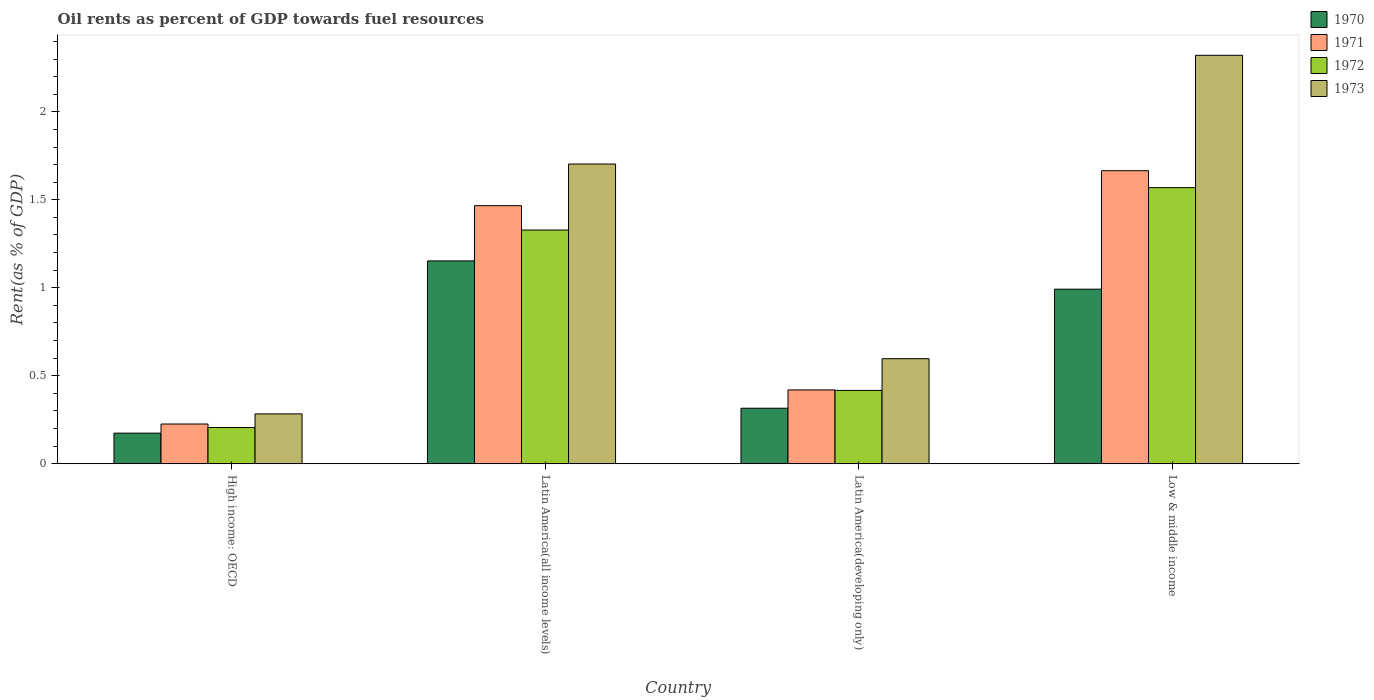How many different coloured bars are there?
Keep it short and to the point. 4. How many groups of bars are there?
Provide a short and direct response. 4. Are the number of bars per tick equal to the number of legend labels?
Your answer should be very brief. Yes. Are the number of bars on each tick of the X-axis equal?
Provide a short and direct response. Yes. How many bars are there on the 1st tick from the left?
Keep it short and to the point. 4. How many bars are there on the 1st tick from the right?
Your answer should be very brief. 4. What is the label of the 1st group of bars from the left?
Ensure brevity in your answer.  High income: OECD. What is the oil rent in 1971 in High income: OECD?
Provide a short and direct response. 0.23. Across all countries, what is the maximum oil rent in 1970?
Your response must be concise. 1.15. Across all countries, what is the minimum oil rent in 1970?
Your answer should be compact. 0.17. In which country was the oil rent in 1970 maximum?
Keep it short and to the point. Latin America(all income levels). In which country was the oil rent in 1973 minimum?
Ensure brevity in your answer.  High income: OECD. What is the total oil rent in 1970 in the graph?
Your response must be concise. 2.63. What is the difference between the oil rent in 1970 in Latin America(all income levels) and that in Latin America(developing only)?
Make the answer very short. 0.84. What is the difference between the oil rent in 1971 in Latin America(all income levels) and the oil rent in 1972 in Low & middle income?
Offer a very short reply. -0.1. What is the average oil rent in 1972 per country?
Provide a succinct answer. 0.88. What is the difference between the oil rent of/in 1973 and oil rent of/in 1970 in Low & middle income?
Make the answer very short. 1.33. In how many countries, is the oil rent in 1970 greater than 0.4 %?
Ensure brevity in your answer.  2. What is the ratio of the oil rent in 1973 in Latin America(developing only) to that in Low & middle income?
Offer a very short reply. 0.26. Is the oil rent in 1972 in High income: OECD less than that in Latin America(developing only)?
Give a very brief answer. Yes. What is the difference between the highest and the second highest oil rent in 1970?
Your response must be concise. -0.16. What is the difference between the highest and the lowest oil rent in 1972?
Provide a short and direct response. 1.36. In how many countries, is the oil rent in 1970 greater than the average oil rent in 1970 taken over all countries?
Offer a terse response. 2. Is the sum of the oil rent in 1972 in High income: OECD and Latin America(developing only) greater than the maximum oil rent in 1971 across all countries?
Offer a very short reply. No. Is it the case that in every country, the sum of the oil rent in 1971 and oil rent in 1972 is greater than the sum of oil rent in 1973 and oil rent in 1970?
Make the answer very short. No. What does the 2nd bar from the left in Low & middle income represents?
Provide a short and direct response. 1971. Are the values on the major ticks of Y-axis written in scientific E-notation?
Ensure brevity in your answer.  No. Does the graph contain grids?
Keep it short and to the point. No. Where does the legend appear in the graph?
Offer a very short reply. Top right. How are the legend labels stacked?
Your response must be concise. Vertical. What is the title of the graph?
Keep it short and to the point. Oil rents as percent of GDP towards fuel resources. Does "1973" appear as one of the legend labels in the graph?
Offer a very short reply. Yes. What is the label or title of the Y-axis?
Provide a short and direct response. Rent(as % of GDP). What is the Rent(as % of GDP) of 1970 in High income: OECD?
Your response must be concise. 0.17. What is the Rent(as % of GDP) of 1971 in High income: OECD?
Ensure brevity in your answer.  0.23. What is the Rent(as % of GDP) of 1972 in High income: OECD?
Your answer should be compact. 0.21. What is the Rent(as % of GDP) in 1973 in High income: OECD?
Your answer should be very brief. 0.28. What is the Rent(as % of GDP) of 1970 in Latin America(all income levels)?
Keep it short and to the point. 1.15. What is the Rent(as % of GDP) in 1971 in Latin America(all income levels)?
Offer a terse response. 1.47. What is the Rent(as % of GDP) in 1972 in Latin America(all income levels)?
Give a very brief answer. 1.33. What is the Rent(as % of GDP) in 1973 in Latin America(all income levels)?
Offer a terse response. 1.7. What is the Rent(as % of GDP) of 1970 in Latin America(developing only)?
Offer a very short reply. 0.32. What is the Rent(as % of GDP) in 1971 in Latin America(developing only)?
Ensure brevity in your answer.  0.42. What is the Rent(as % of GDP) of 1972 in Latin America(developing only)?
Give a very brief answer. 0.42. What is the Rent(as % of GDP) of 1973 in Latin America(developing only)?
Keep it short and to the point. 0.6. What is the Rent(as % of GDP) in 1970 in Low & middle income?
Offer a terse response. 0.99. What is the Rent(as % of GDP) of 1971 in Low & middle income?
Your response must be concise. 1.67. What is the Rent(as % of GDP) of 1972 in Low & middle income?
Give a very brief answer. 1.57. What is the Rent(as % of GDP) of 1973 in Low & middle income?
Offer a very short reply. 2.32. Across all countries, what is the maximum Rent(as % of GDP) in 1970?
Your answer should be very brief. 1.15. Across all countries, what is the maximum Rent(as % of GDP) of 1971?
Provide a short and direct response. 1.67. Across all countries, what is the maximum Rent(as % of GDP) of 1972?
Make the answer very short. 1.57. Across all countries, what is the maximum Rent(as % of GDP) of 1973?
Provide a short and direct response. 2.32. Across all countries, what is the minimum Rent(as % of GDP) of 1970?
Make the answer very short. 0.17. Across all countries, what is the minimum Rent(as % of GDP) of 1971?
Make the answer very short. 0.23. Across all countries, what is the minimum Rent(as % of GDP) of 1972?
Offer a very short reply. 0.21. Across all countries, what is the minimum Rent(as % of GDP) in 1973?
Ensure brevity in your answer.  0.28. What is the total Rent(as % of GDP) of 1970 in the graph?
Provide a succinct answer. 2.63. What is the total Rent(as % of GDP) of 1971 in the graph?
Ensure brevity in your answer.  3.78. What is the total Rent(as % of GDP) in 1972 in the graph?
Keep it short and to the point. 3.52. What is the total Rent(as % of GDP) in 1973 in the graph?
Your answer should be compact. 4.9. What is the difference between the Rent(as % of GDP) in 1970 in High income: OECD and that in Latin America(all income levels)?
Your response must be concise. -0.98. What is the difference between the Rent(as % of GDP) of 1971 in High income: OECD and that in Latin America(all income levels)?
Ensure brevity in your answer.  -1.24. What is the difference between the Rent(as % of GDP) of 1972 in High income: OECD and that in Latin America(all income levels)?
Your answer should be very brief. -1.12. What is the difference between the Rent(as % of GDP) of 1973 in High income: OECD and that in Latin America(all income levels)?
Your answer should be compact. -1.42. What is the difference between the Rent(as % of GDP) in 1970 in High income: OECD and that in Latin America(developing only)?
Ensure brevity in your answer.  -0.14. What is the difference between the Rent(as % of GDP) in 1971 in High income: OECD and that in Latin America(developing only)?
Ensure brevity in your answer.  -0.19. What is the difference between the Rent(as % of GDP) of 1972 in High income: OECD and that in Latin America(developing only)?
Offer a terse response. -0.21. What is the difference between the Rent(as % of GDP) in 1973 in High income: OECD and that in Latin America(developing only)?
Make the answer very short. -0.31. What is the difference between the Rent(as % of GDP) in 1970 in High income: OECD and that in Low & middle income?
Offer a terse response. -0.82. What is the difference between the Rent(as % of GDP) of 1971 in High income: OECD and that in Low & middle income?
Your answer should be very brief. -1.44. What is the difference between the Rent(as % of GDP) in 1972 in High income: OECD and that in Low & middle income?
Give a very brief answer. -1.36. What is the difference between the Rent(as % of GDP) in 1973 in High income: OECD and that in Low & middle income?
Ensure brevity in your answer.  -2.04. What is the difference between the Rent(as % of GDP) in 1970 in Latin America(all income levels) and that in Latin America(developing only)?
Provide a short and direct response. 0.84. What is the difference between the Rent(as % of GDP) in 1971 in Latin America(all income levels) and that in Latin America(developing only)?
Make the answer very short. 1.05. What is the difference between the Rent(as % of GDP) in 1972 in Latin America(all income levels) and that in Latin America(developing only)?
Provide a short and direct response. 0.91. What is the difference between the Rent(as % of GDP) in 1973 in Latin America(all income levels) and that in Latin America(developing only)?
Provide a short and direct response. 1.11. What is the difference between the Rent(as % of GDP) in 1970 in Latin America(all income levels) and that in Low & middle income?
Offer a terse response. 0.16. What is the difference between the Rent(as % of GDP) in 1971 in Latin America(all income levels) and that in Low & middle income?
Provide a succinct answer. -0.2. What is the difference between the Rent(as % of GDP) of 1972 in Latin America(all income levels) and that in Low & middle income?
Your answer should be compact. -0.24. What is the difference between the Rent(as % of GDP) in 1973 in Latin America(all income levels) and that in Low & middle income?
Make the answer very short. -0.62. What is the difference between the Rent(as % of GDP) in 1970 in Latin America(developing only) and that in Low & middle income?
Make the answer very short. -0.68. What is the difference between the Rent(as % of GDP) of 1971 in Latin America(developing only) and that in Low & middle income?
Offer a terse response. -1.25. What is the difference between the Rent(as % of GDP) in 1972 in Latin America(developing only) and that in Low & middle income?
Ensure brevity in your answer.  -1.15. What is the difference between the Rent(as % of GDP) in 1973 in Latin America(developing only) and that in Low & middle income?
Give a very brief answer. -1.72. What is the difference between the Rent(as % of GDP) in 1970 in High income: OECD and the Rent(as % of GDP) in 1971 in Latin America(all income levels)?
Your response must be concise. -1.29. What is the difference between the Rent(as % of GDP) in 1970 in High income: OECD and the Rent(as % of GDP) in 1972 in Latin America(all income levels)?
Keep it short and to the point. -1.15. What is the difference between the Rent(as % of GDP) in 1970 in High income: OECD and the Rent(as % of GDP) in 1973 in Latin America(all income levels)?
Provide a short and direct response. -1.53. What is the difference between the Rent(as % of GDP) of 1971 in High income: OECD and the Rent(as % of GDP) of 1972 in Latin America(all income levels)?
Your response must be concise. -1.1. What is the difference between the Rent(as % of GDP) in 1971 in High income: OECD and the Rent(as % of GDP) in 1973 in Latin America(all income levels)?
Keep it short and to the point. -1.48. What is the difference between the Rent(as % of GDP) in 1972 in High income: OECD and the Rent(as % of GDP) in 1973 in Latin America(all income levels)?
Offer a very short reply. -1.5. What is the difference between the Rent(as % of GDP) in 1970 in High income: OECD and the Rent(as % of GDP) in 1971 in Latin America(developing only)?
Your answer should be very brief. -0.25. What is the difference between the Rent(as % of GDP) of 1970 in High income: OECD and the Rent(as % of GDP) of 1972 in Latin America(developing only)?
Your answer should be very brief. -0.24. What is the difference between the Rent(as % of GDP) of 1970 in High income: OECD and the Rent(as % of GDP) of 1973 in Latin America(developing only)?
Give a very brief answer. -0.42. What is the difference between the Rent(as % of GDP) of 1971 in High income: OECD and the Rent(as % of GDP) of 1972 in Latin America(developing only)?
Give a very brief answer. -0.19. What is the difference between the Rent(as % of GDP) in 1971 in High income: OECD and the Rent(as % of GDP) in 1973 in Latin America(developing only)?
Provide a succinct answer. -0.37. What is the difference between the Rent(as % of GDP) of 1972 in High income: OECD and the Rent(as % of GDP) of 1973 in Latin America(developing only)?
Your response must be concise. -0.39. What is the difference between the Rent(as % of GDP) in 1970 in High income: OECD and the Rent(as % of GDP) in 1971 in Low & middle income?
Your answer should be compact. -1.49. What is the difference between the Rent(as % of GDP) of 1970 in High income: OECD and the Rent(as % of GDP) of 1972 in Low & middle income?
Your response must be concise. -1.4. What is the difference between the Rent(as % of GDP) in 1970 in High income: OECD and the Rent(as % of GDP) in 1973 in Low & middle income?
Keep it short and to the point. -2.15. What is the difference between the Rent(as % of GDP) in 1971 in High income: OECD and the Rent(as % of GDP) in 1972 in Low & middle income?
Your answer should be compact. -1.34. What is the difference between the Rent(as % of GDP) in 1971 in High income: OECD and the Rent(as % of GDP) in 1973 in Low & middle income?
Your answer should be very brief. -2.1. What is the difference between the Rent(as % of GDP) in 1972 in High income: OECD and the Rent(as % of GDP) in 1973 in Low & middle income?
Your response must be concise. -2.12. What is the difference between the Rent(as % of GDP) of 1970 in Latin America(all income levels) and the Rent(as % of GDP) of 1971 in Latin America(developing only)?
Give a very brief answer. 0.73. What is the difference between the Rent(as % of GDP) in 1970 in Latin America(all income levels) and the Rent(as % of GDP) in 1972 in Latin America(developing only)?
Offer a very short reply. 0.74. What is the difference between the Rent(as % of GDP) in 1970 in Latin America(all income levels) and the Rent(as % of GDP) in 1973 in Latin America(developing only)?
Provide a short and direct response. 0.56. What is the difference between the Rent(as % of GDP) of 1971 in Latin America(all income levels) and the Rent(as % of GDP) of 1972 in Latin America(developing only)?
Give a very brief answer. 1.05. What is the difference between the Rent(as % of GDP) in 1971 in Latin America(all income levels) and the Rent(as % of GDP) in 1973 in Latin America(developing only)?
Keep it short and to the point. 0.87. What is the difference between the Rent(as % of GDP) of 1972 in Latin America(all income levels) and the Rent(as % of GDP) of 1973 in Latin America(developing only)?
Provide a succinct answer. 0.73. What is the difference between the Rent(as % of GDP) of 1970 in Latin America(all income levels) and the Rent(as % of GDP) of 1971 in Low & middle income?
Give a very brief answer. -0.51. What is the difference between the Rent(as % of GDP) of 1970 in Latin America(all income levels) and the Rent(as % of GDP) of 1972 in Low & middle income?
Your answer should be very brief. -0.42. What is the difference between the Rent(as % of GDP) in 1970 in Latin America(all income levels) and the Rent(as % of GDP) in 1973 in Low & middle income?
Provide a short and direct response. -1.17. What is the difference between the Rent(as % of GDP) in 1971 in Latin America(all income levels) and the Rent(as % of GDP) in 1972 in Low & middle income?
Make the answer very short. -0.1. What is the difference between the Rent(as % of GDP) of 1971 in Latin America(all income levels) and the Rent(as % of GDP) of 1973 in Low & middle income?
Your answer should be very brief. -0.85. What is the difference between the Rent(as % of GDP) of 1972 in Latin America(all income levels) and the Rent(as % of GDP) of 1973 in Low & middle income?
Your response must be concise. -0.99. What is the difference between the Rent(as % of GDP) of 1970 in Latin America(developing only) and the Rent(as % of GDP) of 1971 in Low & middle income?
Your answer should be very brief. -1.35. What is the difference between the Rent(as % of GDP) in 1970 in Latin America(developing only) and the Rent(as % of GDP) in 1972 in Low & middle income?
Make the answer very short. -1.25. What is the difference between the Rent(as % of GDP) of 1970 in Latin America(developing only) and the Rent(as % of GDP) of 1973 in Low & middle income?
Your answer should be compact. -2.01. What is the difference between the Rent(as % of GDP) in 1971 in Latin America(developing only) and the Rent(as % of GDP) in 1972 in Low & middle income?
Provide a short and direct response. -1.15. What is the difference between the Rent(as % of GDP) of 1971 in Latin America(developing only) and the Rent(as % of GDP) of 1973 in Low & middle income?
Offer a very short reply. -1.9. What is the difference between the Rent(as % of GDP) of 1972 in Latin America(developing only) and the Rent(as % of GDP) of 1973 in Low & middle income?
Keep it short and to the point. -1.9. What is the average Rent(as % of GDP) of 1970 per country?
Your answer should be very brief. 0.66. What is the average Rent(as % of GDP) of 1971 per country?
Provide a succinct answer. 0.94. What is the average Rent(as % of GDP) of 1972 per country?
Your answer should be very brief. 0.88. What is the average Rent(as % of GDP) of 1973 per country?
Offer a terse response. 1.23. What is the difference between the Rent(as % of GDP) of 1970 and Rent(as % of GDP) of 1971 in High income: OECD?
Offer a very short reply. -0.05. What is the difference between the Rent(as % of GDP) of 1970 and Rent(as % of GDP) of 1972 in High income: OECD?
Provide a succinct answer. -0.03. What is the difference between the Rent(as % of GDP) in 1970 and Rent(as % of GDP) in 1973 in High income: OECD?
Provide a short and direct response. -0.11. What is the difference between the Rent(as % of GDP) of 1971 and Rent(as % of GDP) of 1973 in High income: OECD?
Offer a terse response. -0.06. What is the difference between the Rent(as % of GDP) of 1972 and Rent(as % of GDP) of 1973 in High income: OECD?
Give a very brief answer. -0.08. What is the difference between the Rent(as % of GDP) of 1970 and Rent(as % of GDP) of 1971 in Latin America(all income levels)?
Give a very brief answer. -0.31. What is the difference between the Rent(as % of GDP) in 1970 and Rent(as % of GDP) in 1972 in Latin America(all income levels)?
Make the answer very short. -0.18. What is the difference between the Rent(as % of GDP) of 1970 and Rent(as % of GDP) of 1973 in Latin America(all income levels)?
Ensure brevity in your answer.  -0.55. What is the difference between the Rent(as % of GDP) in 1971 and Rent(as % of GDP) in 1972 in Latin America(all income levels)?
Your response must be concise. 0.14. What is the difference between the Rent(as % of GDP) in 1971 and Rent(as % of GDP) in 1973 in Latin America(all income levels)?
Ensure brevity in your answer.  -0.24. What is the difference between the Rent(as % of GDP) in 1972 and Rent(as % of GDP) in 1973 in Latin America(all income levels)?
Provide a succinct answer. -0.38. What is the difference between the Rent(as % of GDP) of 1970 and Rent(as % of GDP) of 1971 in Latin America(developing only)?
Your answer should be compact. -0.1. What is the difference between the Rent(as % of GDP) in 1970 and Rent(as % of GDP) in 1972 in Latin America(developing only)?
Your response must be concise. -0.1. What is the difference between the Rent(as % of GDP) in 1970 and Rent(as % of GDP) in 1973 in Latin America(developing only)?
Offer a very short reply. -0.28. What is the difference between the Rent(as % of GDP) in 1971 and Rent(as % of GDP) in 1972 in Latin America(developing only)?
Your answer should be very brief. 0. What is the difference between the Rent(as % of GDP) of 1971 and Rent(as % of GDP) of 1973 in Latin America(developing only)?
Offer a very short reply. -0.18. What is the difference between the Rent(as % of GDP) in 1972 and Rent(as % of GDP) in 1973 in Latin America(developing only)?
Offer a very short reply. -0.18. What is the difference between the Rent(as % of GDP) of 1970 and Rent(as % of GDP) of 1971 in Low & middle income?
Offer a very short reply. -0.67. What is the difference between the Rent(as % of GDP) of 1970 and Rent(as % of GDP) of 1972 in Low & middle income?
Your answer should be compact. -0.58. What is the difference between the Rent(as % of GDP) of 1970 and Rent(as % of GDP) of 1973 in Low & middle income?
Your answer should be compact. -1.33. What is the difference between the Rent(as % of GDP) in 1971 and Rent(as % of GDP) in 1972 in Low & middle income?
Your response must be concise. 0.1. What is the difference between the Rent(as % of GDP) of 1971 and Rent(as % of GDP) of 1973 in Low & middle income?
Provide a succinct answer. -0.66. What is the difference between the Rent(as % of GDP) of 1972 and Rent(as % of GDP) of 1973 in Low & middle income?
Your answer should be very brief. -0.75. What is the ratio of the Rent(as % of GDP) in 1970 in High income: OECD to that in Latin America(all income levels)?
Offer a very short reply. 0.15. What is the ratio of the Rent(as % of GDP) of 1971 in High income: OECD to that in Latin America(all income levels)?
Your response must be concise. 0.15. What is the ratio of the Rent(as % of GDP) of 1972 in High income: OECD to that in Latin America(all income levels)?
Offer a terse response. 0.15. What is the ratio of the Rent(as % of GDP) in 1973 in High income: OECD to that in Latin America(all income levels)?
Keep it short and to the point. 0.17. What is the ratio of the Rent(as % of GDP) of 1970 in High income: OECD to that in Latin America(developing only)?
Your answer should be very brief. 0.55. What is the ratio of the Rent(as % of GDP) in 1971 in High income: OECD to that in Latin America(developing only)?
Your response must be concise. 0.54. What is the ratio of the Rent(as % of GDP) in 1972 in High income: OECD to that in Latin America(developing only)?
Ensure brevity in your answer.  0.49. What is the ratio of the Rent(as % of GDP) in 1973 in High income: OECD to that in Latin America(developing only)?
Offer a terse response. 0.47. What is the ratio of the Rent(as % of GDP) in 1970 in High income: OECD to that in Low & middle income?
Your answer should be compact. 0.18. What is the ratio of the Rent(as % of GDP) of 1971 in High income: OECD to that in Low & middle income?
Keep it short and to the point. 0.14. What is the ratio of the Rent(as % of GDP) in 1972 in High income: OECD to that in Low & middle income?
Keep it short and to the point. 0.13. What is the ratio of the Rent(as % of GDP) of 1973 in High income: OECD to that in Low & middle income?
Give a very brief answer. 0.12. What is the ratio of the Rent(as % of GDP) of 1970 in Latin America(all income levels) to that in Latin America(developing only)?
Make the answer very short. 3.65. What is the ratio of the Rent(as % of GDP) in 1971 in Latin America(all income levels) to that in Latin America(developing only)?
Your response must be concise. 3.5. What is the ratio of the Rent(as % of GDP) of 1972 in Latin America(all income levels) to that in Latin America(developing only)?
Provide a succinct answer. 3.19. What is the ratio of the Rent(as % of GDP) in 1973 in Latin America(all income levels) to that in Latin America(developing only)?
Provide a short and direct response. 2.85. What is the ratio of the Rent(as % of GDP) of 1970 in Latin America(all income levels) to that in Low & middle income?
Offer a very short reply. 1.16. What is the ratio of the Rent(as % of GDP) of 1971 in Latin America(all income levels) to that in Low & middle income?
Give a very brief answer. 0.88. What is the ratio of the Rent(as % of GDP) in 1972 in Latin America(all income levels) to that in Low & middle income?
Provide a succinct answer. 0.85. What is the ratio of the Rent(as % of GDP) in 1973 in Latin America(all income levels) to that in Low & middle income?
Provide a succinct answer. 0.73. What is the ratio of the Rent(as % of GDP) in 1970 in Latin America(developing only) to that in Low & middle income?
Your answer should be compact. 0.32. What is the ratio of the Rent(as % of GDP) in 1971 in Latin America(developing only) to that in Low & middle income?
Your answer should be compact. 0.25. What is the ratio of the Rent(as % of GDP) of 1972 in Latin America(developing only) to that in Low & middle income?
Offer a very short reply. 0.27. What is the ratio of the Rent(as % of GDP) in 1973 in Latin America(developing only) to that in Low & middle income?
Ensure brevity in your answer.  0.26. What is the difference between the highest and the second highest Rent(as % of GDP) of 1970?
Your answer should be compact. 0.16. What is the difference between the highest and the second highest Rent(as % of GDP) in 1971?
Ensure brevity in your answer.  0.2. What is the difference between the highest and the second highest Rent(as % of GDP) in 1972?
Your answer should be very brief. 0.24. What is the difference between the highest and the second highest Rent(as % of GDP) of 1973?
Your answer should be compact. 0.62. What is the difference between the highest and the lowest Rent(as % of GDP) of 1970?
Make the answer very short. 0.98. What is the difference between the highest and the lowest Rent(as % of GDP) of 1971?
Offer a very short reply. 1.44. What is the difference between the highest and the lowest Rent(as % of GDP) of 1972?
Ensure brevity in your answer.  1.36. What is the difference between the highest and the lowest Rent(as % of GDP) of 1973?
Provide a succinct answer. 2.04. 